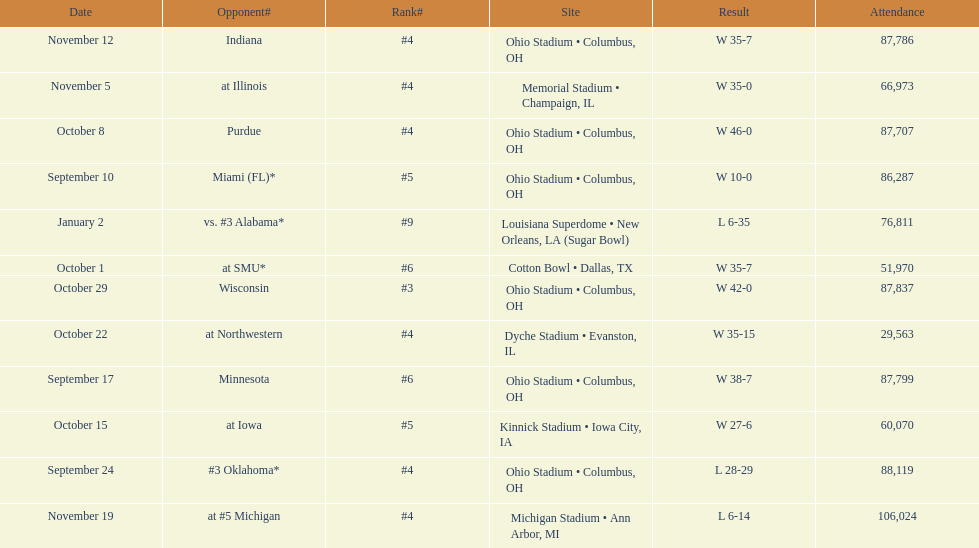How many games did this team win during this season? 9. 